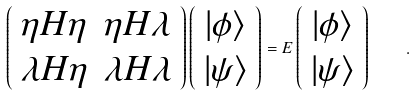Convert formula to latex. <formula><loc_0><loc_0><loc_500><loc_500>\left ( \begin{array} { c c } \eta H \eta & \eta H \lambda \\ \lambda H \eta & \lambda H \lambda \end{array} \right ) \left ( \begin{array} { c } | \phi \rangle \\ | \psi \rangle \end{array} \right ) = E \left ( \begin{array} { c } | \phi \rangle \\ | \psi \rangle \end{array} \right ) \quad .</formula> 